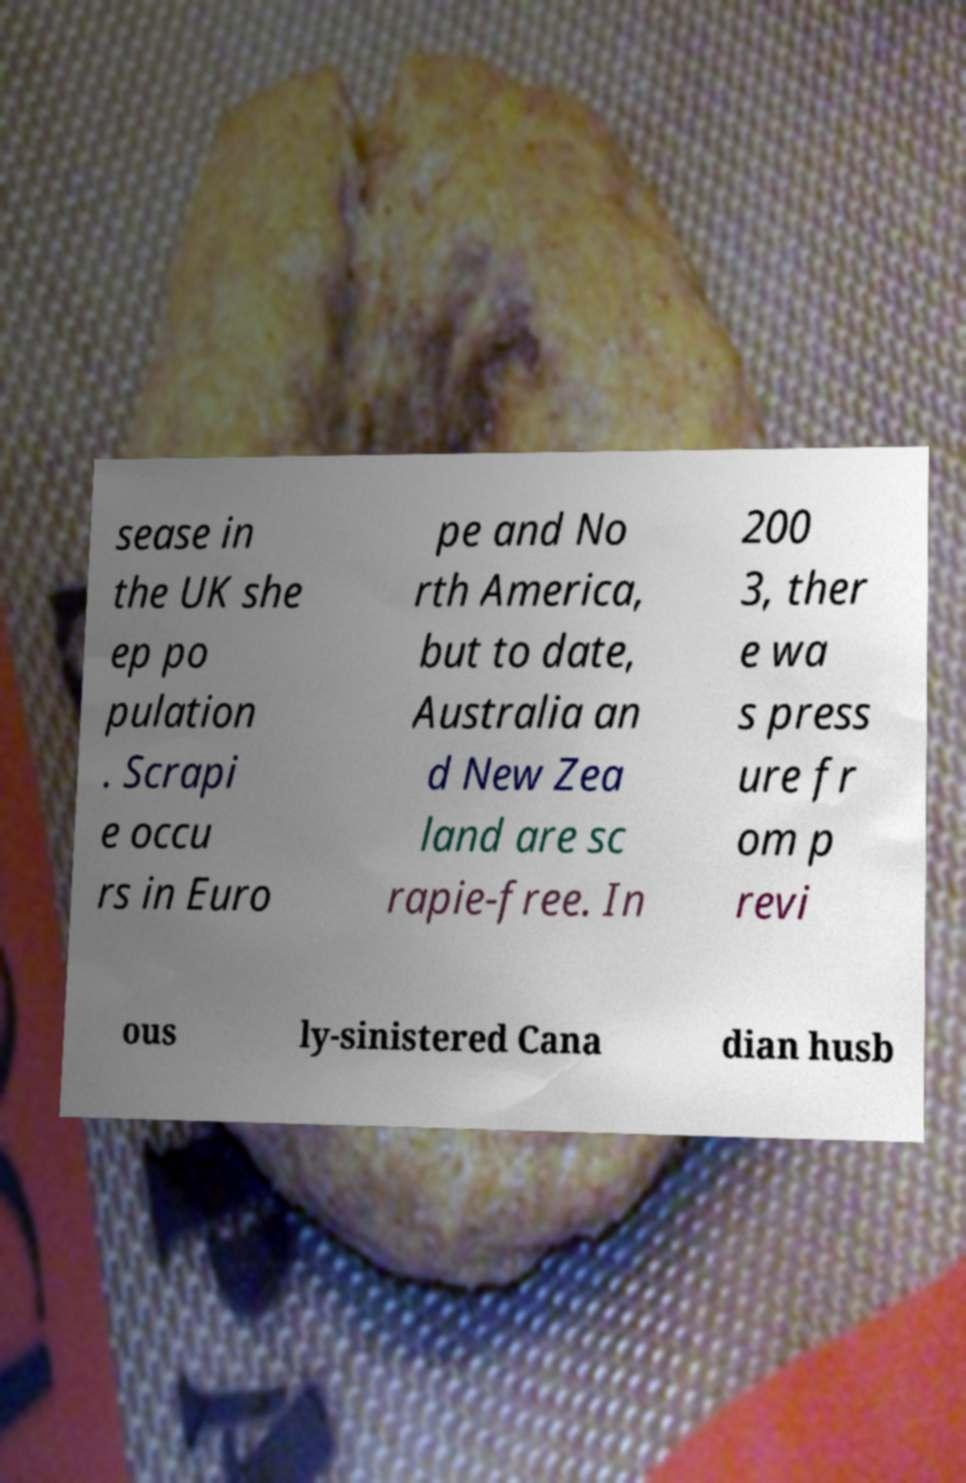There's text embedded in this image that I need extracted. Can you transcribe it verbatim? sease in the UK she ep po pulation . Scrapi e occu rs in Euro pe and No rth America, but to date, Australia an d New Zea land are sc rapie-free. In 200 3, ther e wa s press ure fr om p revi ous ly-sinistered Cana dian husb 